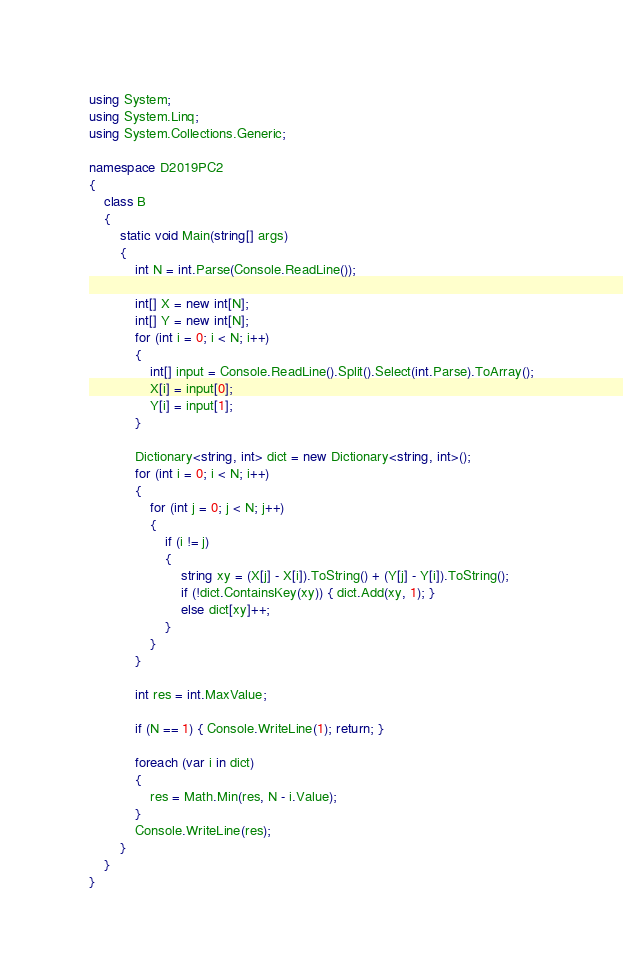Convert code to text. <code><loc_0><loc_0><loc_500><loc_500><_C#_>using System;
using System.Linq;
using System.Collections.Generic;

namespace D2019PC2
{
    class B
    {
        static void Main(string[] args)
        {
            int N = int.Parse(Console.ReadLine());

            int[] X = new int[N];
            int[] Y = new int[N];
            for (int i = 0; i < N; i++)
            {
                int[] input = Console.ReadLine().Split().Select(int.Parse).ToArray();
                X[i] = input[0];
                Y[i] = input[1];
            }

            Dictionary<string, int> dict = new Dictionary<string, int>();
            for (int i = 0; i < N; i++)
            {
                for (int j = 0; j < N; j++)
                {
                    if (i != j)
                    {
                        string xy = (X[j] - X[i]).ToString() + (Y[j] - Y[i]).ToString();
                        if (!dict.ContainsKey(xy)) { dict.Add(xy, 1); }
                        else dict[xy]++;
                    }
                }
            }

            int res = int.MaxValue;

            if (N == 1) { Console.WriteLine(1); return; }

            foreach (var i in dict)
            {
                res = Math.Min(res, N - i.Value);
            }
            Console.WriteLine(res);
        }
    }
}
</code> 